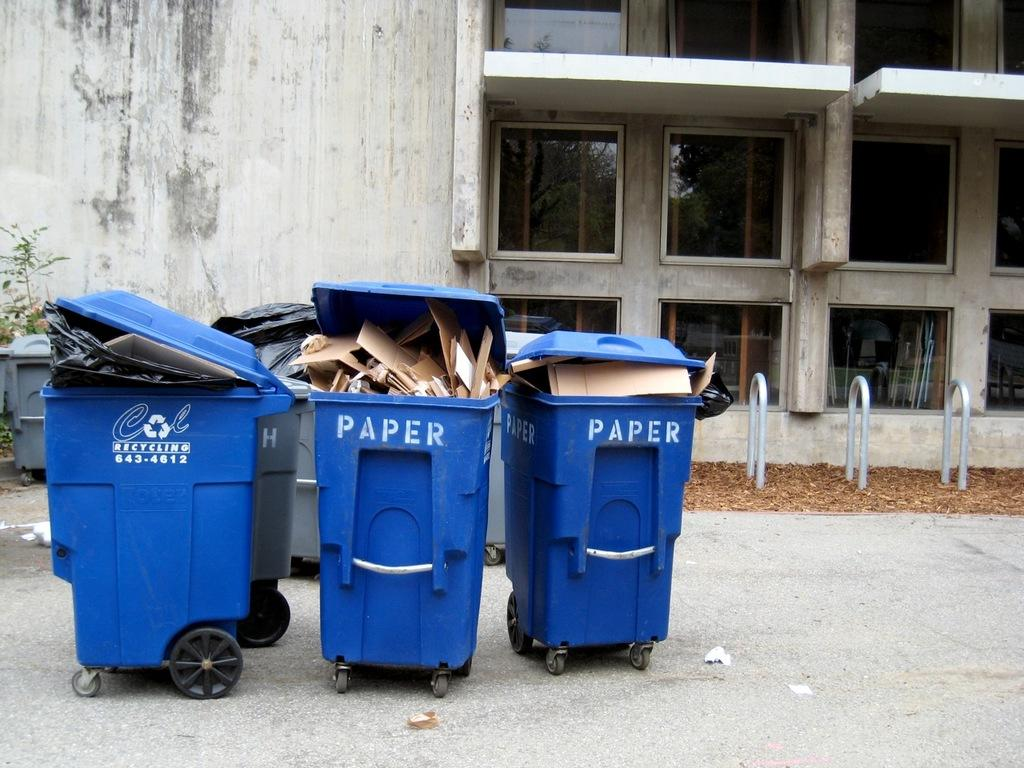<image>
Give a short and clear explanation of the subsequent image. Three blue bins next to one another with one saying PAPER. 